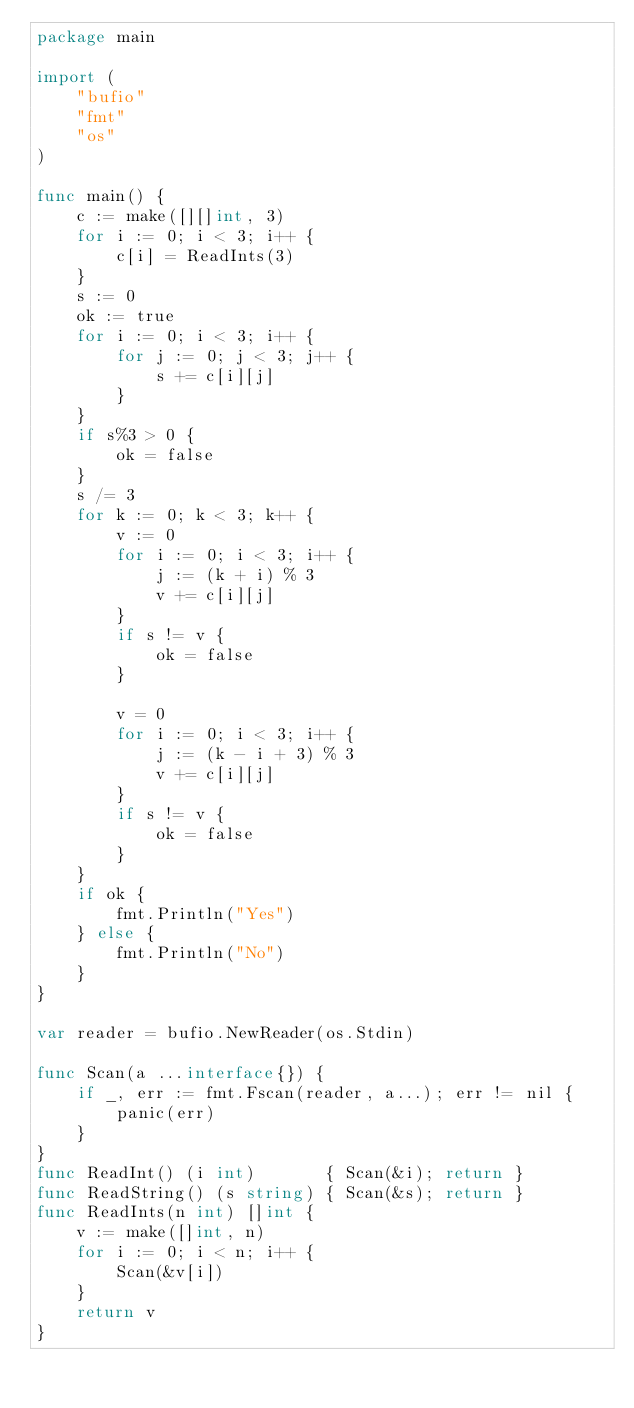<code> <loc_0><loc_0><loc_500><loc_500><_Go_>package main

import (
	"bufio"
	"fmt"
	"os"
)

func main() {
	c := make([][]int, 3)
	for i := 0; i < 3; i++ {
		c[i] = ReadInts(3)
	}
	s := 0
	ok := true
	for i := 0; i < 3; i++ {
		for j := 0; j < 3; j++ {
			s += c[i][j]
		}
	}
	if s%3 > 0 {
		ok = false
	}
	s /= 3
	for k := 0; k < 3; k++ {
		v := 0
		for i := 0; i < 3; i++ {
			j := (k + i) % 3
			v += c[i][j]
		}
		if s != v {
			ok = false
		}

		v = 0
		for i := 0; i < 3; i++ {
			j := (k - i + 3) % 3
			v += c[i][j]
		}
		if s != v {
			ok = false
		}
	}
	if ok {
		fmt.Println("Yes")
	} else {
		fmt.Println("No")
	}
}

var reader = bufio.NewReader(os.Stdin)

func Scan(a ...interface{}) {
	if _, err := fmt.Fscan(reader, a...); err != nil {
		panic(err)
	}
}
func ReadInt() (i int)       { Scan(&i); return }
func ReadString() (s string) { Scan(&s); return }
func ReadInts(n int) []int {
	v := make([]int, n)
	for i := 0; i < n; i++ {
		Scan(&v[i])
	}
	return v
}
</code> 